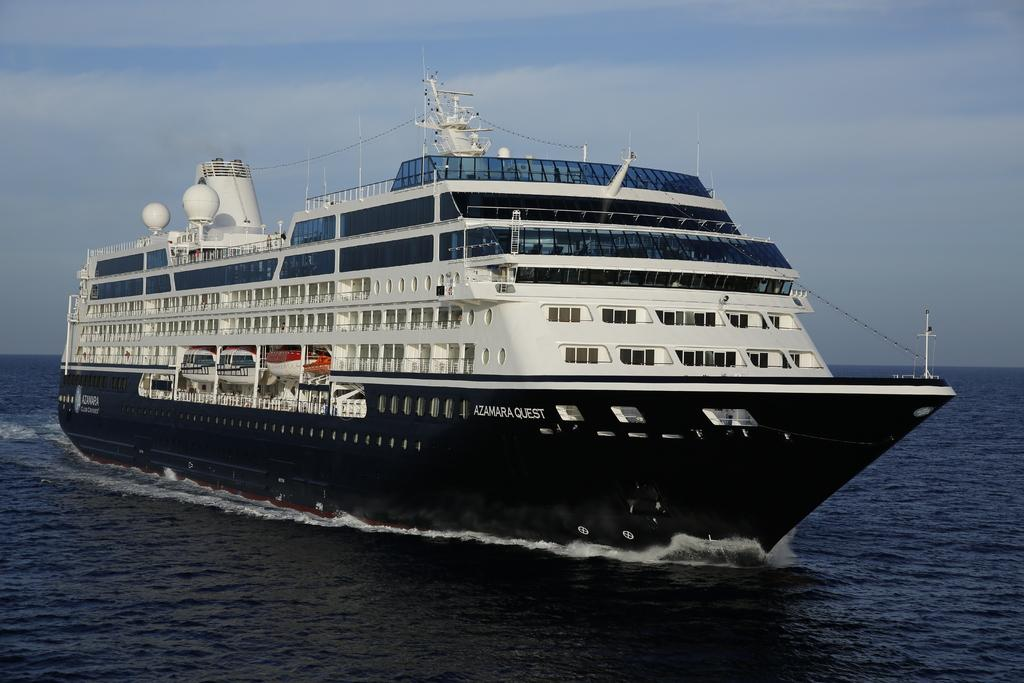Where was the picture taken? The picture was clicked outside. What is the main subject in the center of the image? There is a ship in the water body in the center of the image. What can be seen written or printed in the image? There is text visible in the image. What type of material is present in the image? Metal rods are present in the image. Are there any other objects or structures visible in the image? Yes, there are other objects in the image. What can be seen in the background of the image? The sky is visible in the background of the image. What type of discussion is taking place between the ship and the snow in the image? There is no snow present in the image, and the ship is an inanimate object, so it cannot engage in a discussion. 